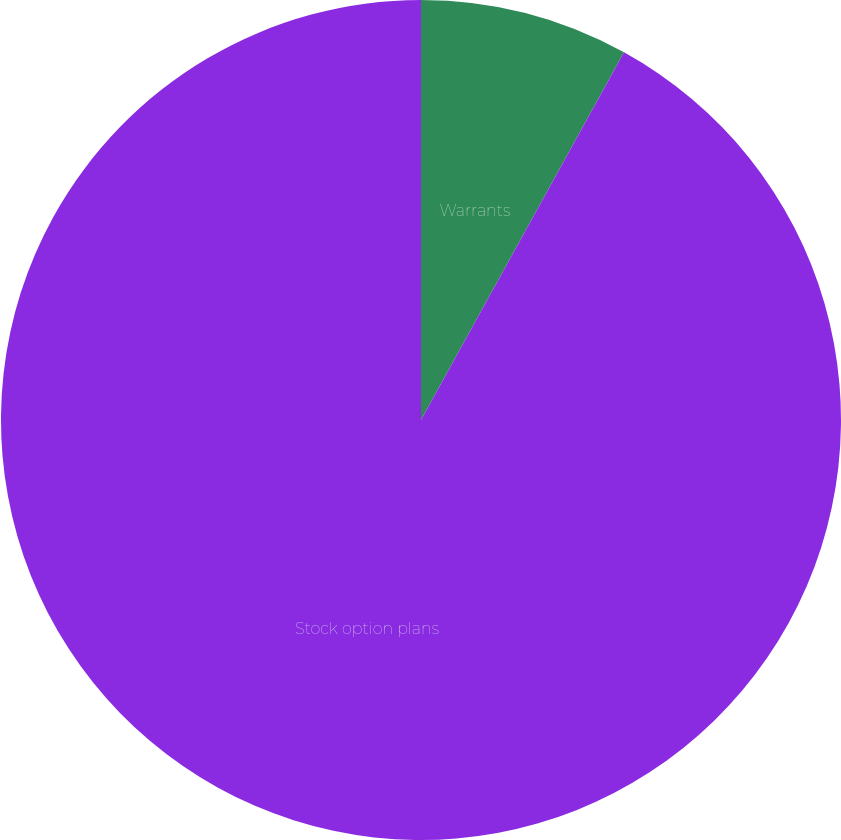Convert chart. <chart><loc_0><loc_0><loc_500><loc_500><pie_chart><fcel>Warrants<fcel>Stock option plans<nl><fcel>8.03%<fcel>91.97%<nl></chart> 